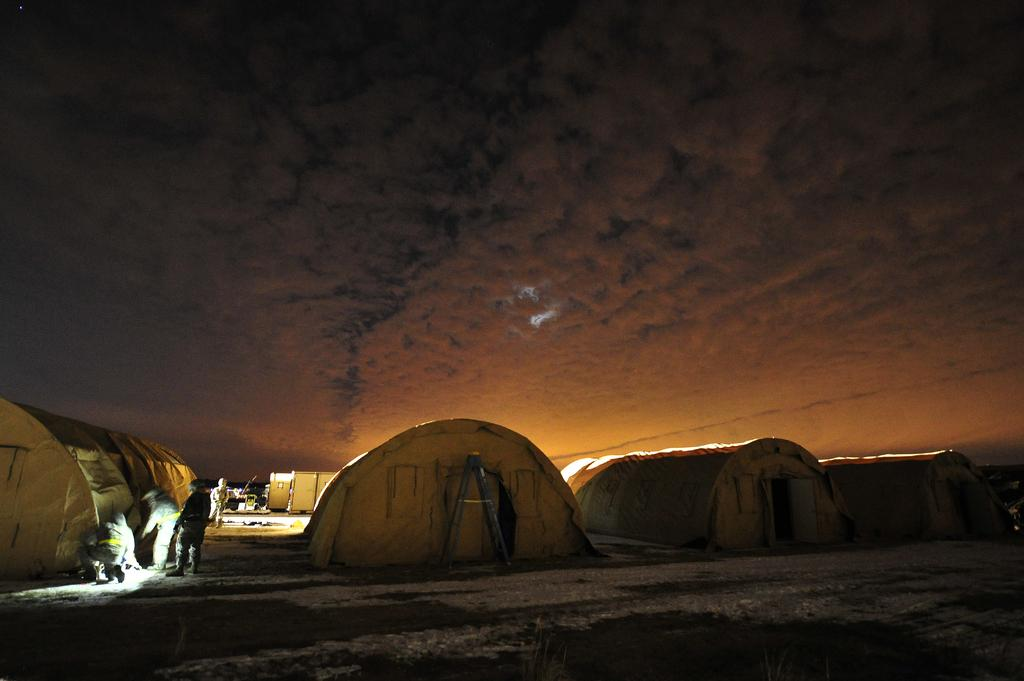What structures are visible on the ground in the image? There are tents on the ground in the image. What can be seen in the background of the image? There is a building in the background of the image. Who or what is present in the image? There are people standing in the image. How would you describe the weather in the image? The sky is cloudy in the image. What type of insect can be seen driving a car in the image? There are no insects or cars present in the image. 